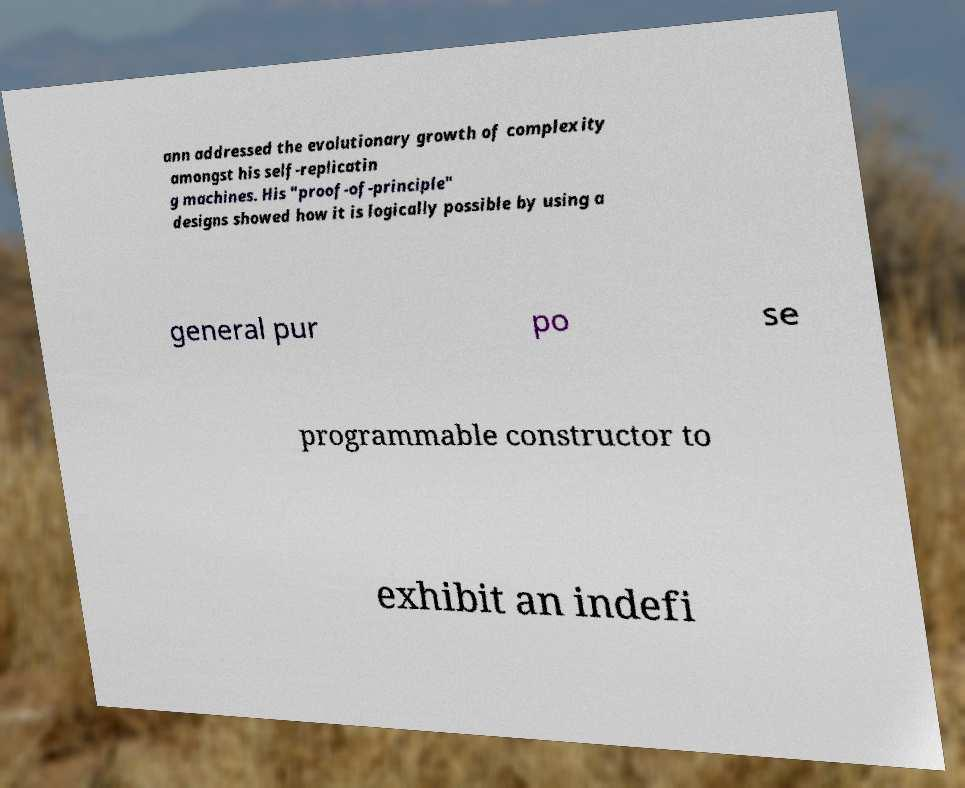Could you extract and type out the text from this image? ann addressed the evolutionary growth of complexity amongst his self-replicatin g machines. His "proof-of-principle" designs showed how it is logically possible by using a general pur po se programmable constructor to exhibit an indefi 